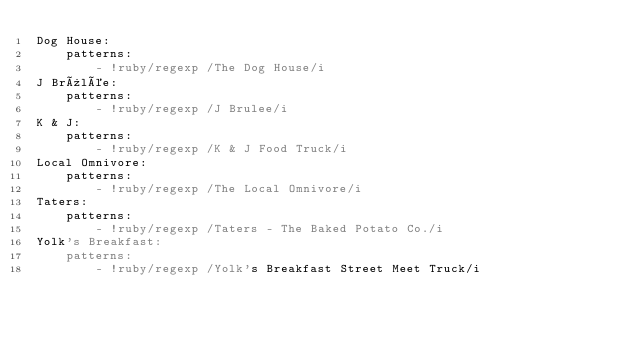<code> <loc_0><loc_0><loc_500><loc_500><_YAML_>Dog House:
    patterns:
        - !ruby/regexp /The Dog House/i
J Brûlée:
    patterns:
        - !ruby/regexp /J Brulee/i
K & J:
    patterns:
        - !ruby/regexp /K & J Food Truck/i
Local Omnivore:
    patterns:
        - !ruby/regexp /The Local Omnivore/i
Taters:
    patterns:
        - !ruby/regexp /Taters - The Baked Potato Co./i
Yolk's Breakfast:
    patterns:
        - !ruby/regexp /Yolk's Breakfast Street Meet Truck/i
</code> 